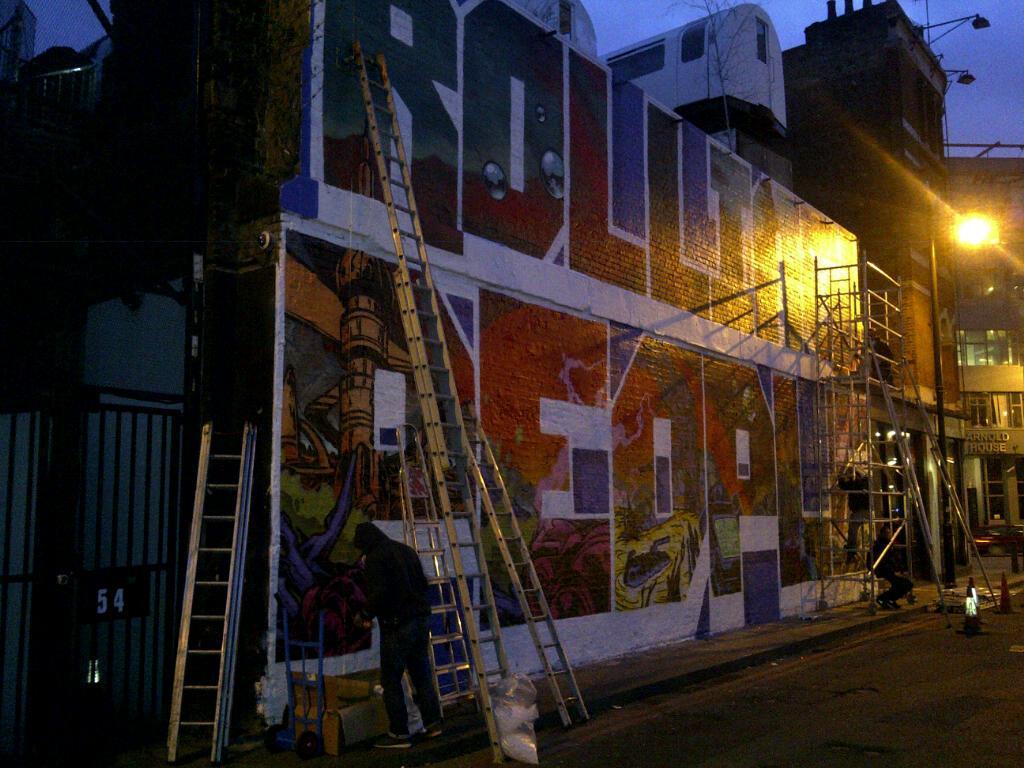Please provide a concise description of this image. In this image I can see the ladders and two people. I can see the traffic cones, cardboard box and the plastic cover on the road. In the background I can see many buildings, light and the sky. 